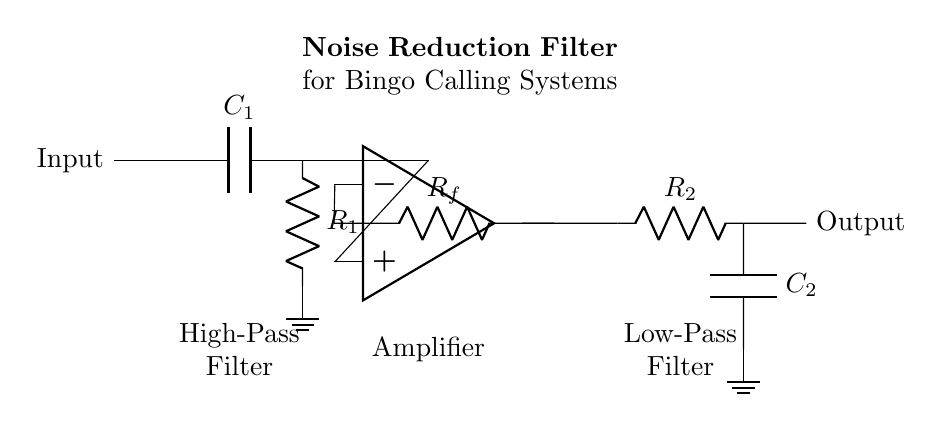What is the role of capacitor C1? Capacitor C1 is part of the high-pass filter, which allows high-frequency signals (like voice) to pass while blocking lower-frequency noise.
Answer: High-pass filter What does the op-amp do in this circuit? The op-amp amplifies the signal after it has gone through the high-pass filter, increasing its strength for further processing.
Answer: Amplification What component connects to the output after R2? After R2, the output is connected to capacitor C2, which is part of the low-pass filter.
Answer: Capacitor C2 How many resistors are in this circuit? There are two resistors, R1 and R2, present in the noise reduction filter circuit.
Answer: Two What is the purpose of the low-pass filter? The low-pass filter, made up of R2 and C2, smooths out the output signal by allowing low-frequency voices to pass while attenuating high-frequency noise.
Answer: Smoothing output What labels are indicated in the diagram? The diagram indicates labels for the high-pass filter, amplifier, and low-pass filter, detailing the sections of the circuit visually.
Answer: High-pass filter, amplifier, low-pass filter What connections lead to ground in this circuit? The connections to ground occur at the terminals of the resistors R1 and R2 and the capacitor C2 to ensure a common reference point in the circuit.
Answer: R1 and R2 